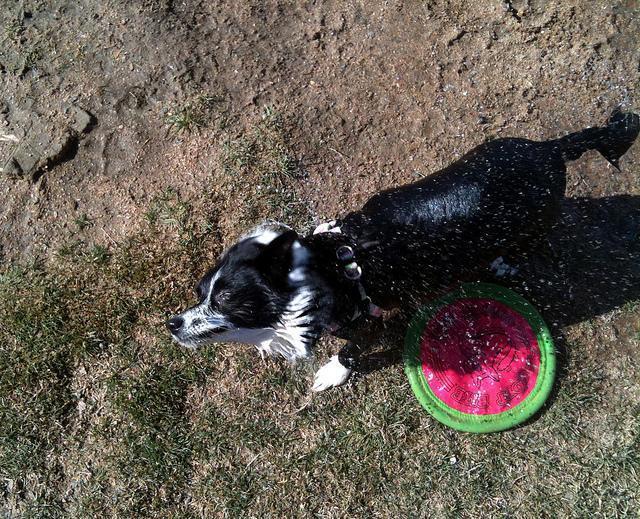How many elephants are there?
Give a very brief answer. 0. 